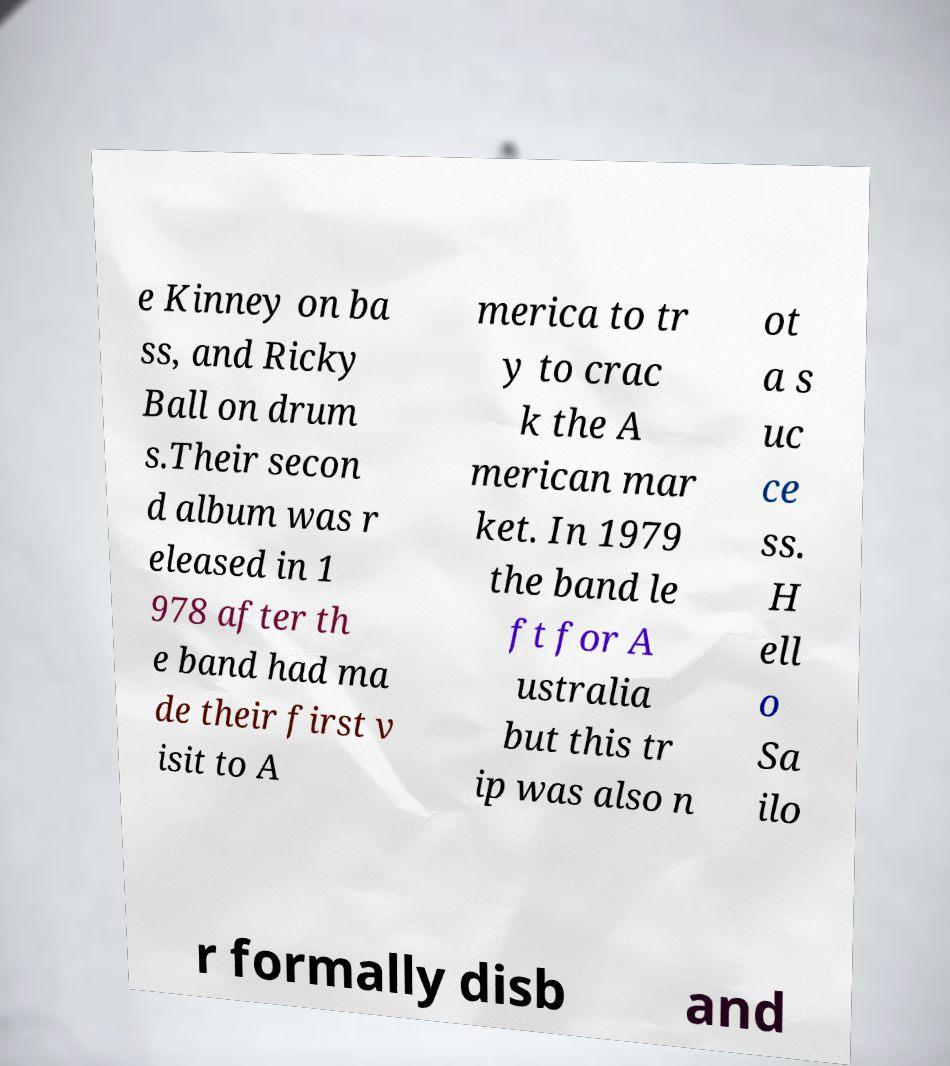Can you read and provide the text displayed in the image?This photo seems to have some interesting text. Can you extract and type it out for me? e Kinney on ba ss, and Ricky Ball on drum s.Their secon d album was r eleased in 1 978 after th e band had ma de their first v isit to A merica to tr y to crac k the A merican mar ket. In 1979 the band le ft for A ustralia but this tr ip was also n ot a s uc ce ss. H ell o Sa ilo r formally disb and 